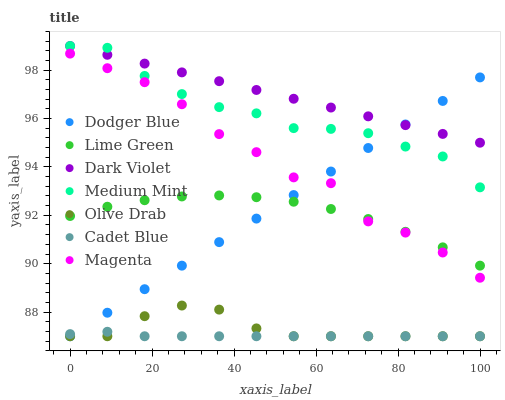Does Cadet Blue have the minimum area under the curve?
Answer yes or no. Yes. Does Dark Violet have the maximum area under the curve?
Answer yes or no. Yes. Does Dark Violet have the minimum area under the curve?
Answer yes or no. No. Does Cadet Blue have the maximum area under the curve?
Answer yes or no. No. Is Dark Violet the smoothest?
Answer yes or no. Yes. Is Magenta the roughest?
Answer yes or no. Yes. Is Cadet Blue the smoothest?
Answer yes or no. No. Is Cadet Blue the roughest?
Answer yes or no. No. Does Cadet Blue have the lowest value?
Answer yes or no. Yes. Does Dark Violet have the lowest value?
Answer yes or no. No. Does Dark Violet have the highest value?
Answer yes or no. Yes. Does Cadet Blue have the highest value?
Answer yes or no. No. Is Cadet Blue less than Magenta?
Answer yes or no. Yes. Is Magenta greater than Olive Drab?
Answer yes or no. Yes. Does Olive Drab intersect Cadet Blue?
Answer yes or no. Yes. Is Olive Drab less than Cadet Blue?
Answer yes or no. No. Is Olive Drab greater than Cadet Blue?
Answer yes or no. No. Does Cadet Blue intersect Magenta?
Answer yes or no. No. 